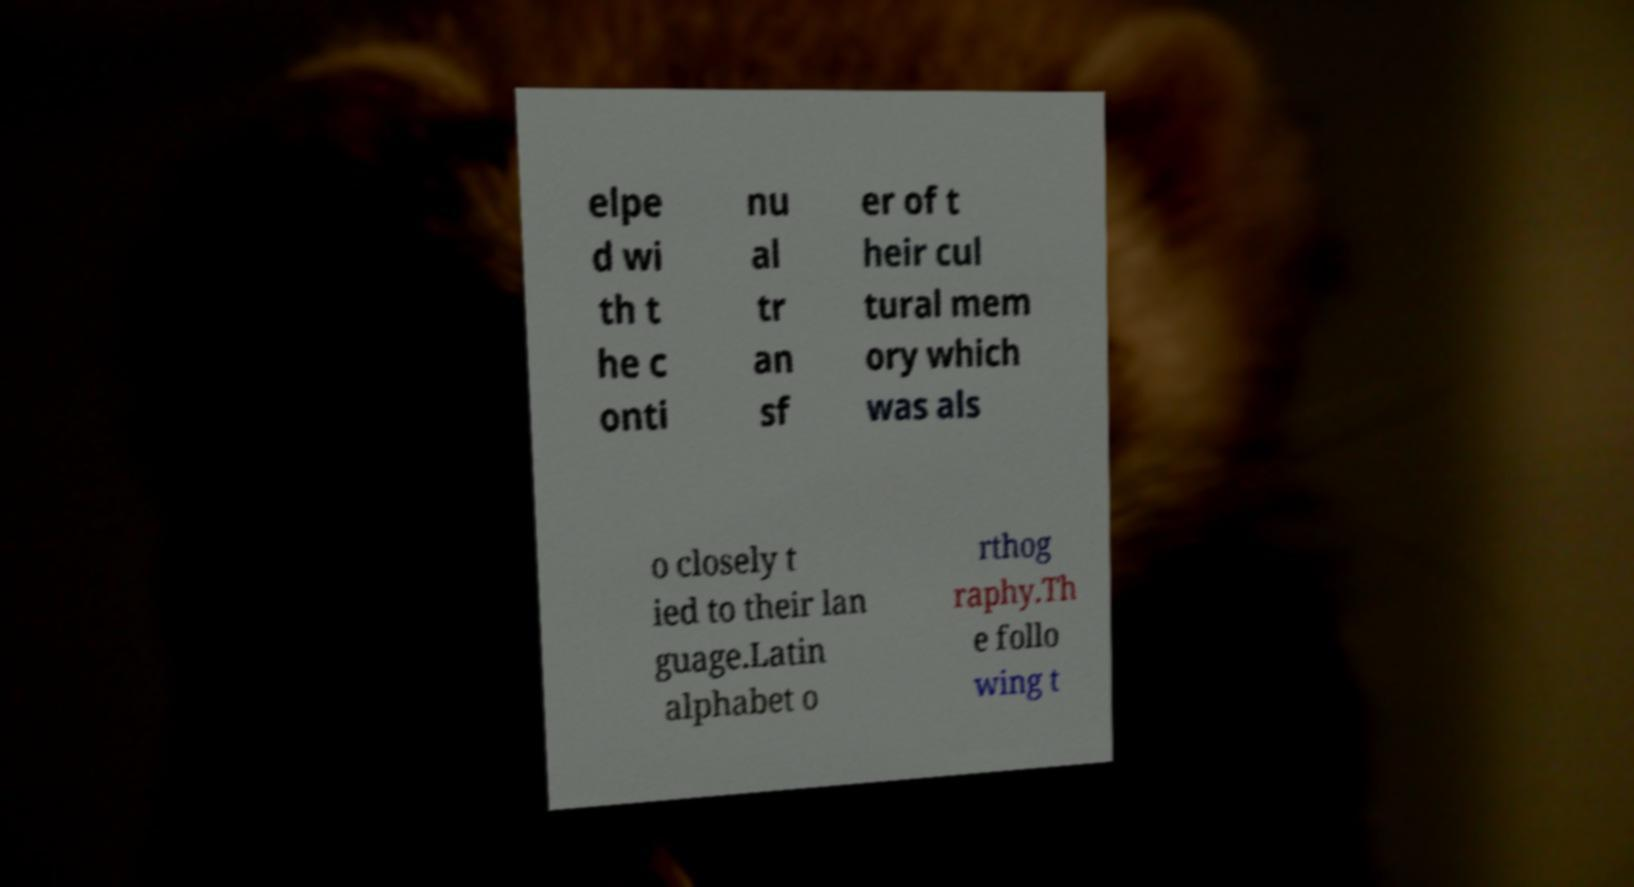Could you assist in decoding the text presented in this image and type it out clearly? elpe d wi th t he c onti nu al tr an sf er of t heir cul tural mem ory which was als o closely t ied to their lan guage.Latin alphabet o rthog raphy.Th e follo wing t 